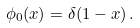<formula> <loc_0><loc_0><loc_500><loc_500>\phi _ { 0 } ( x ) = \delta ( 1 - x ) \, .</formula> 